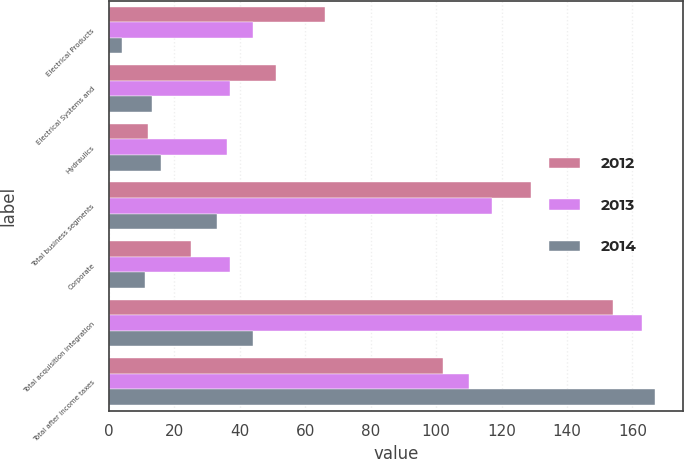<chart> <loc_0><loc_0><loc_500><loc_500><stacked_bar_chart><ecel><fcel>Electrical Products<fcel>Electrical Systems and<fcel>Hydraulics<fcel>Total business segments<fcel>Corporate<fcel>Total acquisition integration<fcel>Total after income taxes<nl><fcel>2012<fcel>66<fcel>51<fcel>12<fcel>129<fcel>25<fcel>154<fcel>102<nl><fcel>2013<fcel>44<fcel>37<fcel>36<fcel>117<fcel>37<fcel>163<fcel>110<nl><fcel>2014<fcel>4<fcel>13<fcel>16<fcel>33<fcel>11<fcel>44<fcel>167<nl></chart> 